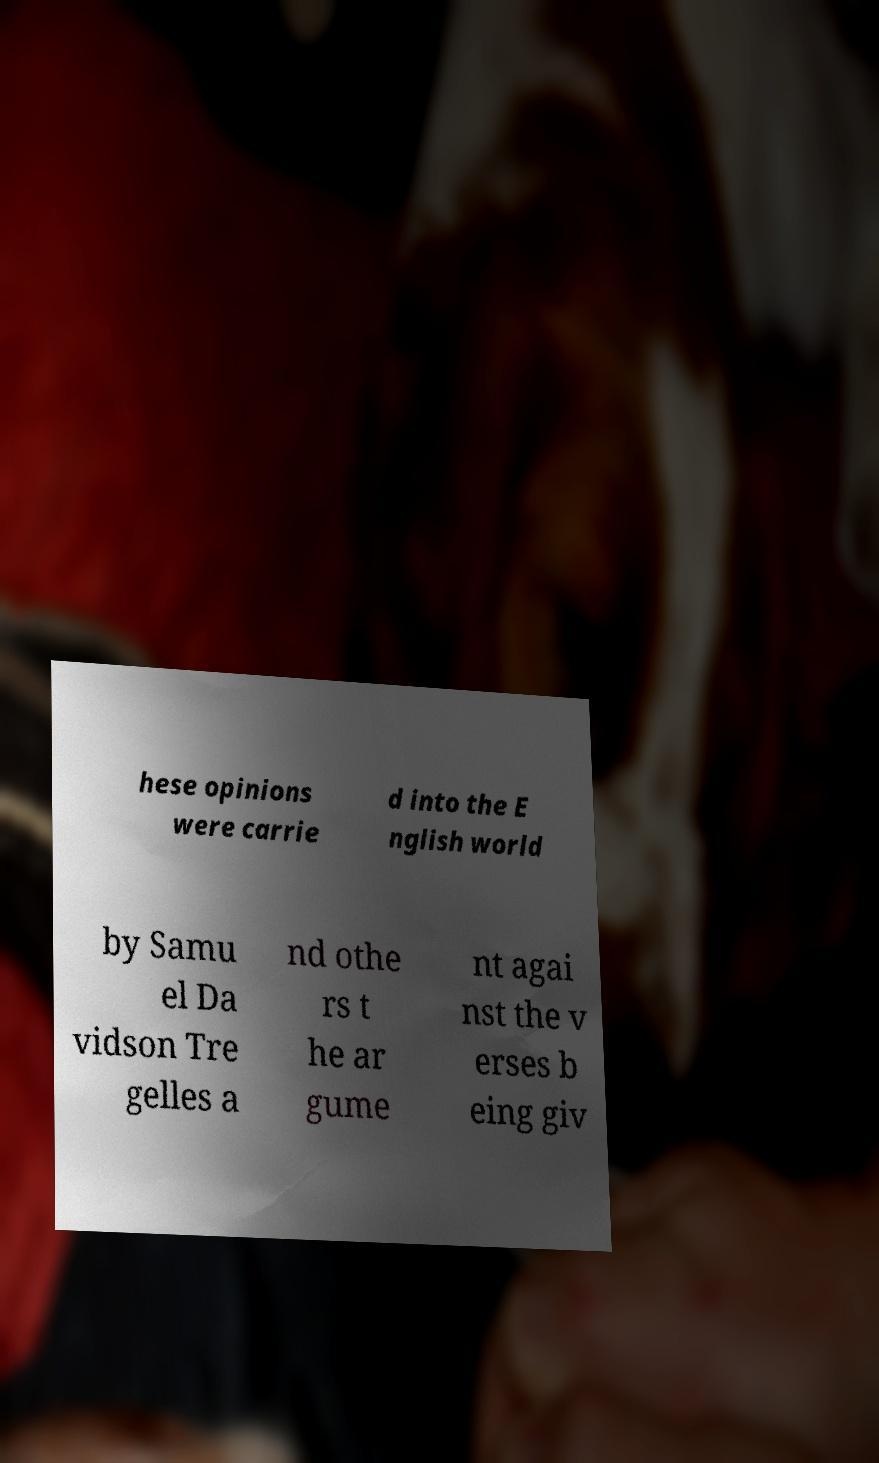Please read and relay the text visible in this image. What does it say? hese opinions were carrie d into the E nglish world by Samu el Da vidson Tre gelles a nd othe rs t he ar gume nt agai nst the v erses b eing giv 